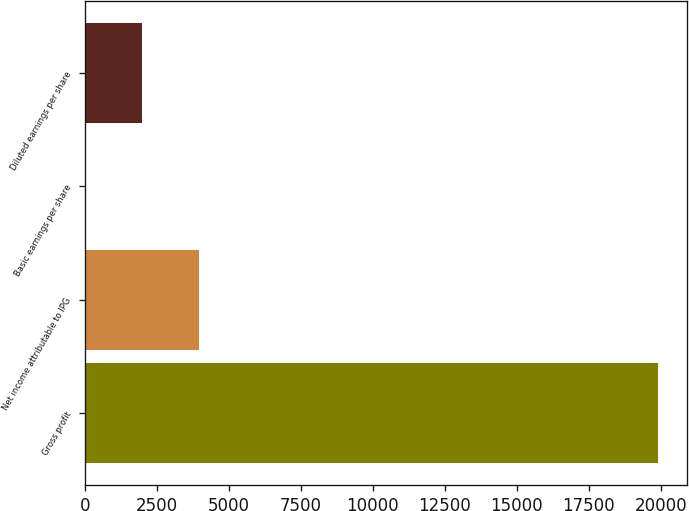<chart> <loc_0><loc_0><loc_500><loc_500><bar_chart><fcel>Gross profit<fcel>Net income attributable to IPG<fcel>Basic earnings per share<fcel>Diluted earnings per share<nl><fcel>19912<fcel>3982.45<fcel>0.07<fcel>1991.26<nl></chart> 